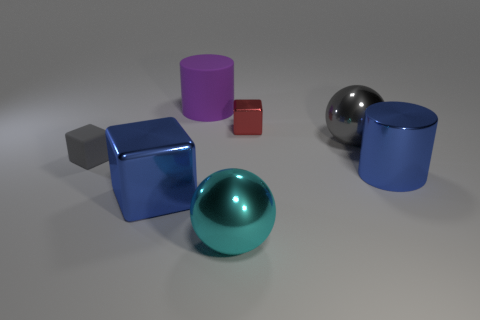What is the shape of the cyan object?
Your answer should be compact. Sphere. There is a small block right of the purple cylinder; is its color the same as the small matte block?
Your response must be concise. No. There is a object that is left of the large purple thing and on the right side of the tiny gray thing; what shape is it?
Offer a very short reply. Cube. What color is the shiny object on the left side of the large matte object?
Keep it short and to the point. Blue. Is there anything else that is the same color as the tiny shiny block?
Provide a succinct answer. No. Is the size of the rubber block the same as the rubber cylinder?
Offer a very short reply. No. There is a thing that is both on the right side of the red thing and to the left of the large blue cylinder; what is its size?
Your answer should be compact. Large. How many red things are the same material as the purple thing?
Your response must be concise. 0. There is a large metal thing that is the same color as the big metal block; what shape is it?
Make the answer very short. Cylinder. What color is the tiny metallic block?
Provide a short and direct response. Red. 